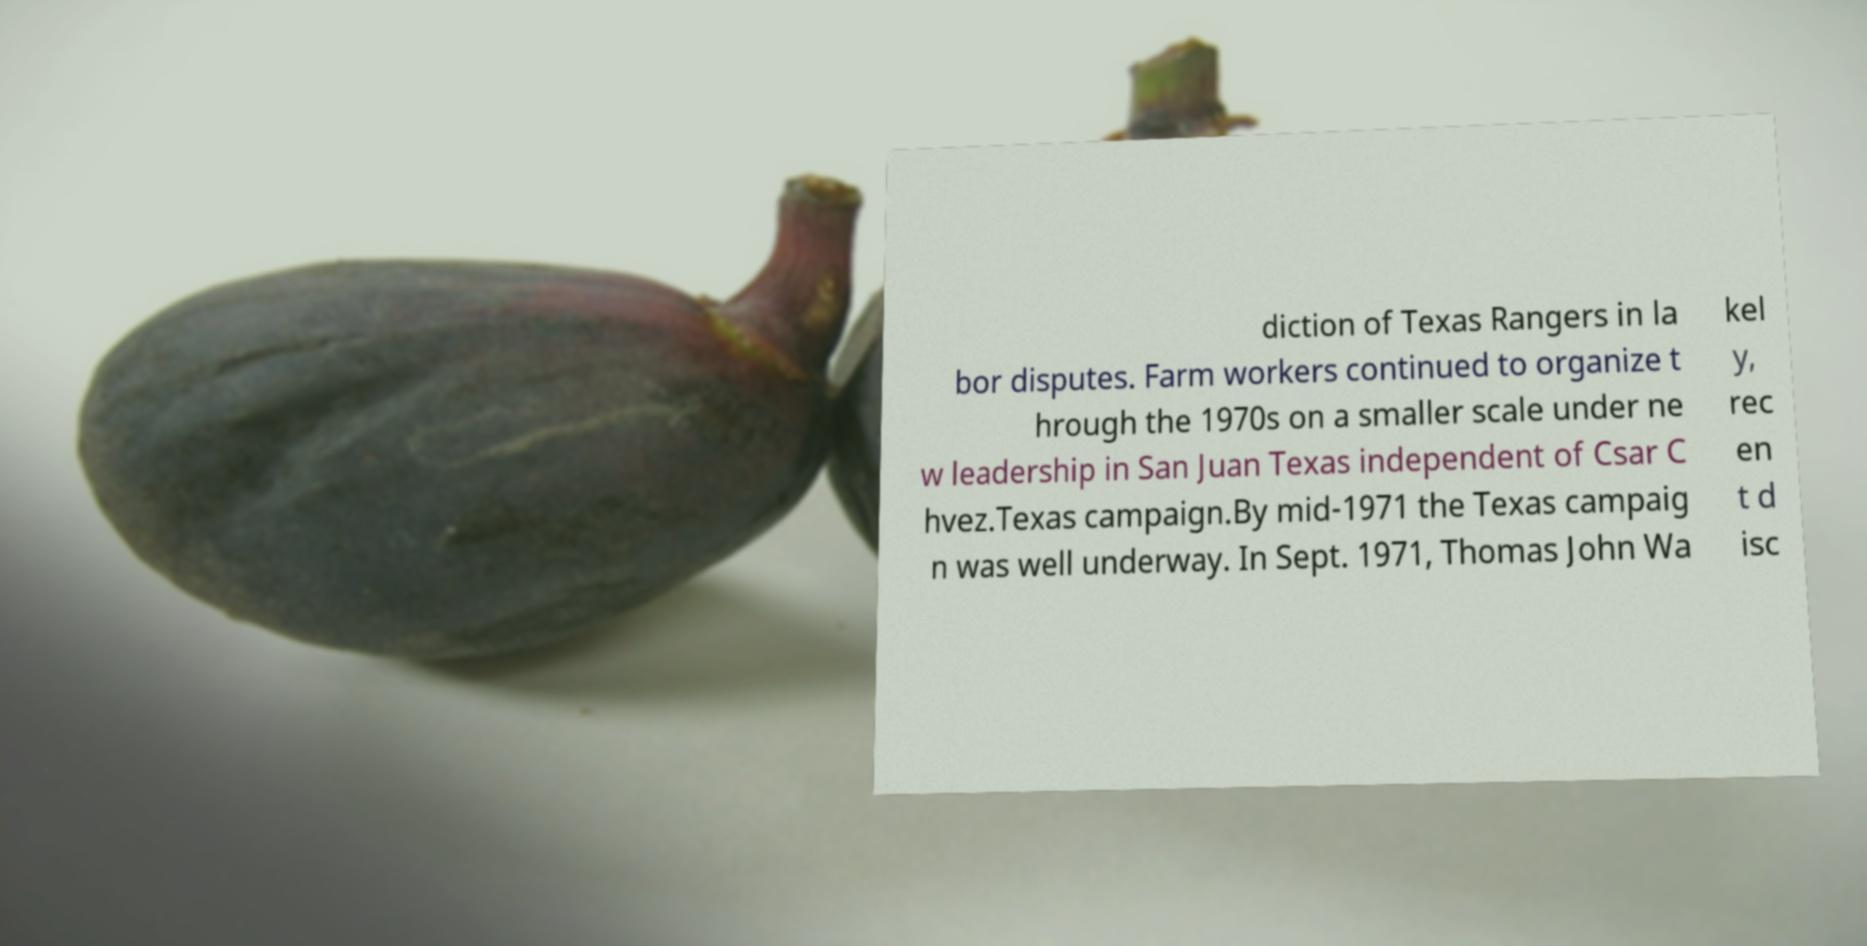Can you accurately transcribe the text from the provided image for me? diction of Texas Rangers in la bor disputes. Farm workers continued to organize t hrough the 1970s on a smaller scale under ne w leadership in San Juan Texas independent of Csar C hvez.Texas campaign.By mid-1971 the Texas campaig n was well underway. In Sept. 1971, Thomas John Wa kel y, rec en t d isc 